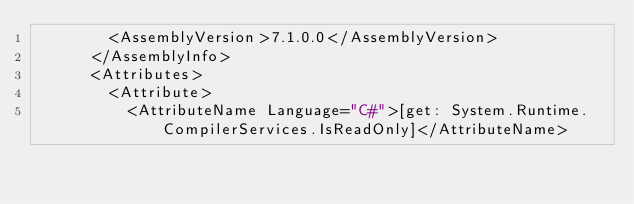<code> <loc_0><loc_0><loc_500><loc_500><_XML_>        <AssemblyVersion>7.1.0.0</AssemblyVersion>
      </AssemblyInfo>
      <Attributes>
        <Attribute>
          <AttributeName Language="C#">[get: System.Runtime.CompilerServices.IsReadOnly]</AttributeName></code> 